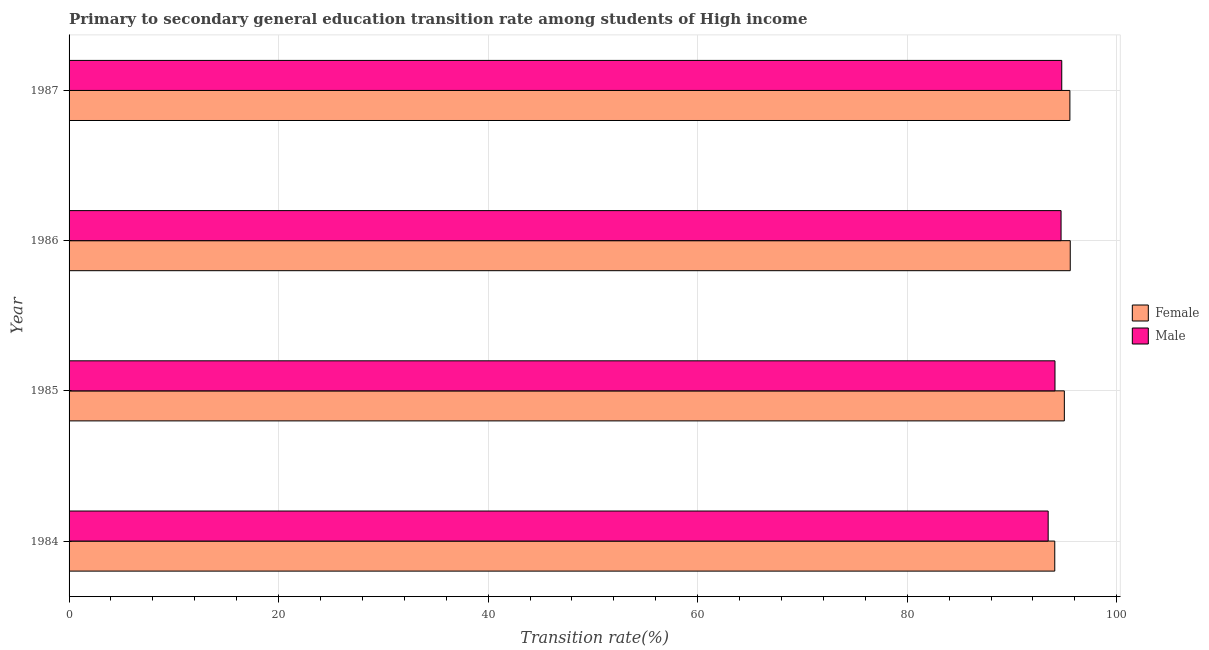How many different coloured bars are there?
Your response must be concise. 2. Are the number of bars per tick equal to the number of legend labels?
Your response must be concise. Yes. What is the transition rate among male students in 1984?
Offer a very short reply. 93.45. Across all years, what is the maximum transition rate among female students?
Your response must be concise. 95.56. Across all years, what is the minimum transition rate among female students?
Your answer should be very brief. 94.08. In which year was the transition rate among female students maximum?
Your answer should be very brief. 1986. In which year was the transition rate among female students minimum?
Your answer should be compact. 1984. What is the total transition rate among female students in the graph?
Ensure brevity in your answer.  380.17. What is the difference between the transition rate among male students in 1984 and that in 1986?
Make the answer very short. -1.23. What is the difference between the transition rate among male students in 1985 and the transition rate among female students in 1984?
Your answer should be compact. 0.02. What is the average transition rate among female students per year?
Keep it short and to the point. 95.04. In the year 1987, what is the difference between the transition rate among female students and transition rate among male students?
Provide a succinct answer. 0.78. In how many years, is the transition rate among male students greater than 80 %?
Provide a short and direct response. 4. What is the ratio of the transition rate among male students in 1986 to that in 1987?
Offer a terse response. 1. Is the difference between the transition rate among male students in 1986 and 1987 greater than the difference between the transition rate among female students in 1986 and 1987?
Make the answer very short. No. What is the difference between the highest and the second highest transition rate among female students?
Provide a succinct answer. 0.03. What is the difference between the highest and the lowest transition rate among female students?
Offer a terse response. 1.48. What does the 1st bar from the bottom in 1984 represents?
Your answer should be compact. Female. Are all the bars in the graph horizontal?
Your answer should be compact. Yes. What is the difference between two consecutive major ticks on the X-axis?
Offer a terse response. 20. Are the values on the major ticks of X-axis written in scientific E-notation?
Your answer should be very brief. No. Does the graph contain grids?
Provide a short and direct response. Yes. Where does the legend appear in the graph?
Give a very brief answer. Center right. How are the legend labels stacked?
Give a very brief answer. Vertical. What is the title of the graph?
Provide a succinct answer. Primary to secondary general education transition rate among students of High income. Does "Secondary school" appear as one of the legend labels in the graph?
Make the answer very short. No. What is the label or title of the X-axis?
Keep it short and to the point. Transition rate(%). What is the Transition rate(%) of Female in 1984?
Your answer should be very brief. 94.08. What is the Transition rate(%) in Male in 1984?
Keep it short and to the point. 93.45. What is the Transition rate(%) of Female in 1985?
Offer a terse response. 95. What is the Transition rate(%) of Male in 1985?
Keep it short and to the point. 94.11. What is the Transition rate(%) in Female in 1986?
Ensure brevity in your answer.  95.56. What is the Transition rate(%) of Male in 1986?
Provide a succinct answer. 94.68. What is the Transition rate(%) in Female in 1987?
Ensure brevity in your answer.  95.53. What is the Transition rate(%) in Male in 1987?
Your answer should be compact. 94.75. Across all years, what is the maximum Transition rate(%) of Female?
Your answer should be compact. 95.56. Across all years, what is the maximum Transition rate(%) in Male?
Ensure brevity in your answer.  94.75. Across all years, what is the minimum Transition rate(%) of Female?
Your answer should be compact. 94.08. Across all years, what is the minimum Transition rate(%) in Male?
Your response must be concise. 93.45. What is the total Transition rate(%) in Female in the graph?
Your response must be concise. 380.17. What is the total Transition rate(%) in Male in the graph?
Offer a terse response. 377. What is the difference between the Transition rate(%) of Female in 1984 and that in 1985?
Your answer should be very brief. -0.91. What is the difference between the Transition rate(%) of Male in 1984 and that in 1985?
Offer a terse response. -0.65. What is the difference between the Transition rate(%) in Female in 1984 and that in 1986?
Provide a short and direct response. -1.48. What is the difference between the Transition rate(%) of Male in 1984 and that in 1986?
Make the answer very short. -1.23. What is the difference between the Transition rate(%) in Female in 1984 and that in 1987?
Your answer should be very brief. -1.44. What is the difference between the Transition rate(%) in Male in 1984 and that in 1987?
Give a very brief answer. -1.3. What is the difference between the Transition rate(%) in Female in 1985 and that in 1986?
Offer a terse response. -0.56. What is the difference between the Transition rate(%) of Male in 1985 and that in 1986?
Provide a succinct answer. -0.58. What is the difference between the Transition rate(%) of Female in 1985 and that in 1987?
Your response must be concise. -0.53. What is the difference between the Transition rate(%) in Male in 1985 and that in 1987?
Provide a succinct answer. -0.65. What is the difference between the Transition rate(%) of Female in 1986 and that in 1987?
Offer a terse response. 0.03. What is the difference between the Transition rate(%) of Male in 1986 and that in 1987?
Provide a succinct answer. -0.07. What is the difference between the Transition rate(%) of Female in 1984 and the Transition rate(%) of Male in 1985?
Offer a terse response. -0.02. What is the difference between the Transition rate(%) of Female in 1984 and the Transition rate(%) of Male in 1986?
Your answer should be very brief. -0.6. What is the difference between the Transition rate(%) in Female in 1984 and the Transition rate(%) in Male in 1987?
Provide a succinct answer. -0.67. What is the difference between the Transition rate(%) in Female in 1985 and the Transition rate(%) in Male in 1986?
Provide a short and direct response. 0.31. What is the difference between the Transition rate(%) in Female in 1985 and the Transition rate(%) in Male in 1987?
Provide a short and direct response. 0.25. What is the difference between the Transition rate(%) in Female in 1986 and the Transition rate(%) in Male in 1987?
Provide a short and direct response. 0.81. What is the average Transition rate(%) of Female per year?
Your response must be concise. 95.04. What is the average Transition rate(%) in Male per year?
Your answer should be very brief. 94.25. In the year 1984, what is the difference between the Transition rate(%) in Female and Transition rate(%) in Male?
Provide a succinct answer. 0.63. In the year 1985, what is the difference between the Transition rate(%) in Female and Transition rate(%) in Male?
Offer a terse response. 0.89. In the year 1986, what is the difference between the Transition rate(%) of Female and Transition rate(%) of Male?
Your answer should be very brief. 0.88. In the year 1987, what is the difference between the Transition rate(%) of Female and Transition rate(%) of Male?
Your answer should be very brief. 0.78. What is the ratio of the Transition rate(%) of Female in 1984 to that in 1985?
Ensure brevity in your answer.  0.99. What is the ratio of the Transition rate(%) of Female in 1984 to that in 1986?
Make the answer very short. 0.98. What is the ratio of the Transition rate(%) of Female in 1984 to that in 1987?
Give a very brief answer. 0.98. What is the ratio of the Transition rate(%) of Male in 1984 to that in 1987?
Provide a succinct answer. 0.99. What is the ratio of the Transition rate(%) of Male in 1985 to that in 1986?
Ensure brevity in your answer.  0.99. What is the ratio of the Transition rate(%) in Female in 1985 to that in 1987?
Your answer should be very brief. 0.99. What is the ratio of the Transition rate(%) of Male in 1985 to that in 1987?
Provide a succinct answer. 0.99. What is the ratio of the Transition rate(%) in Female in 1986 to that in 1987?
Ensure brevity in your answer.  1. What is the ratio of the Transition rate(%) in Male in 1986 to that in 1987?
Ensure brevity in your answer.  1. What is the difference between the highest and the second highest Transition rate(%) in Female?
Offer a terse response. 0.03. What is the difference between the highest and the second highest Transition rate(%) in Male?
Provide a succinct answer. 0.07. What is the difference between the highest and the lowest Transition rate(%) in Female?
Give a very brief answer. 1.48. What is the difference between the highest and the lowest Transition rate(%) in Male?
Keep it short and to the point. 1.3. 